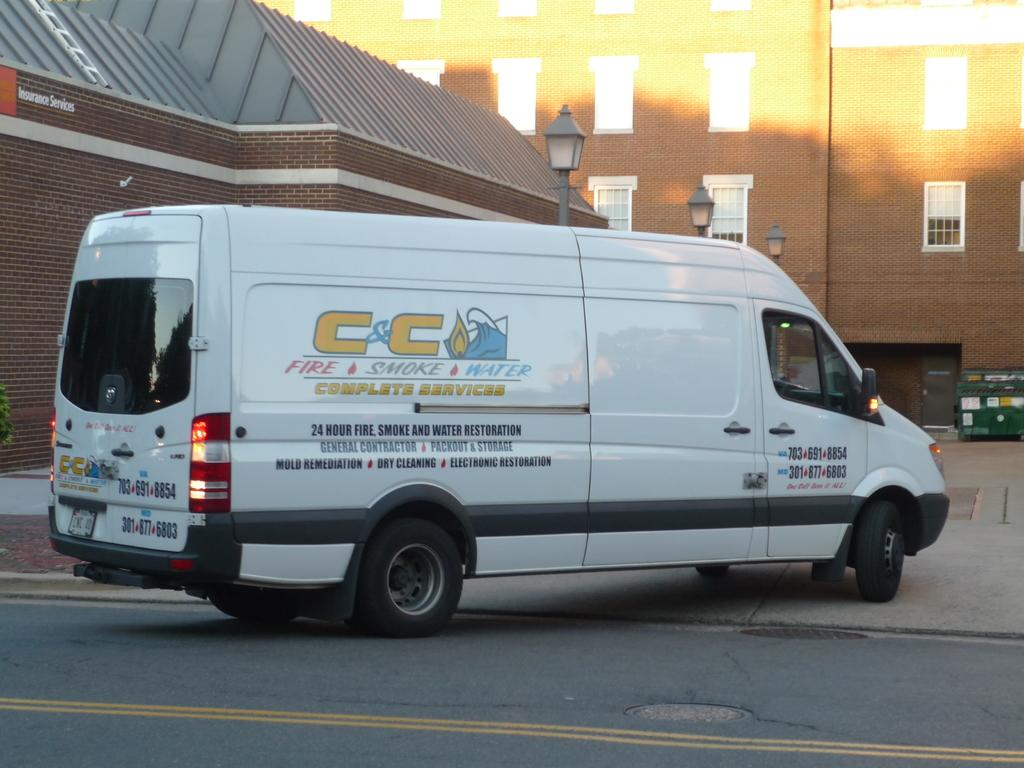<image>
Give a short and clear explanation of the subsequent image. The white van driving by advertises that it has 24 hour fire, smoke and water restoration services. 